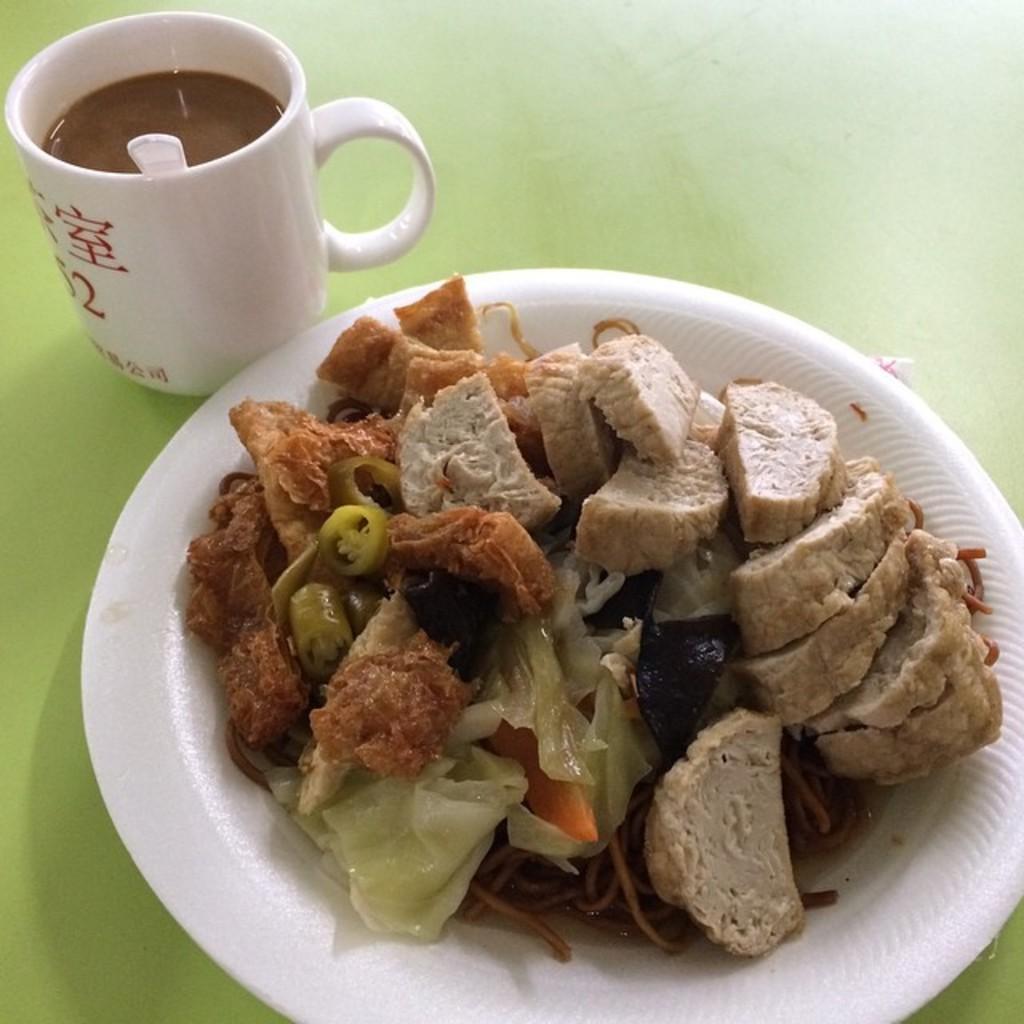Describe this image in one or two sentences. This image consists of food kept on a plate. Beside that, there is a cup of coffee. The plate and cup are kept on a table. 